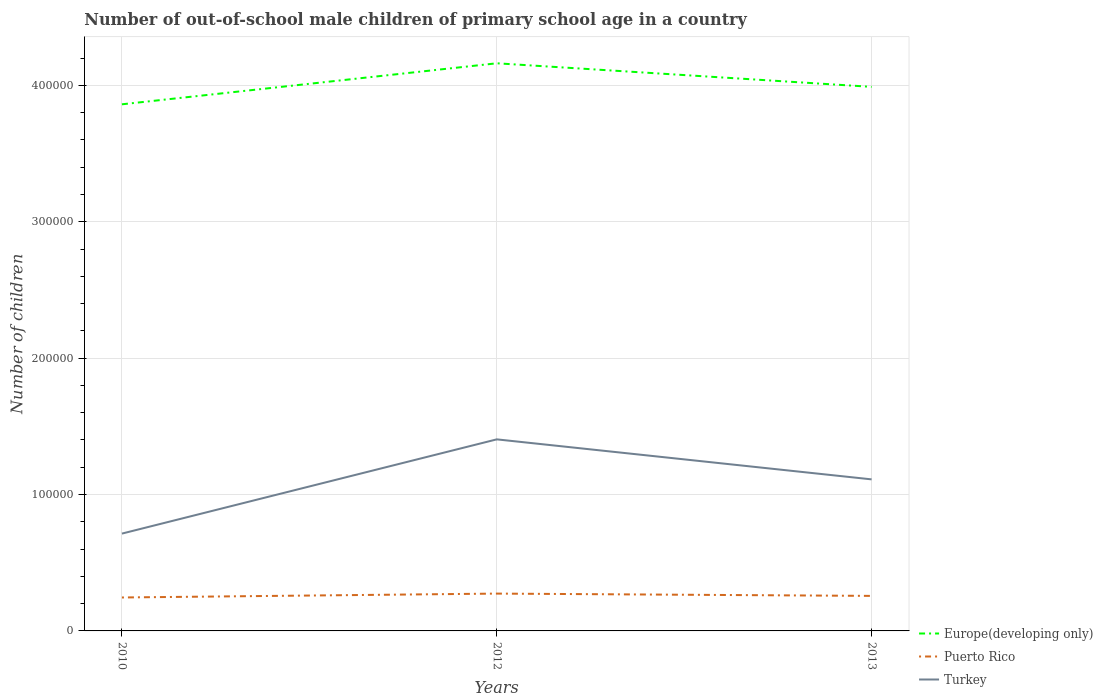Does the line corresponding to Puerto Rico intersect with the line corresponding to Europe(developing only)?
Provide a succinct answer. No. Across all years, what is the maximum number of out-of-school male children in Turkey?
Provide a succinct answer. 7.14e+04. In which year was the number of out-of-school male children in Puerto Rico maximum?
Ensure brevity in your answer.  2010. What is the total number of out-of-school male children in Turkey in the graph?
Offer a very short reply. -6.91e+04. What is the difference between the highest and the second highest number of out-of-school male children in Turkey?
Give a very brief answer. 6.91e+04. What is the difference between the highest and the lowest number of out-of-school male children in Turkey?
Keep it short and to the point. 2. How many lines are there?
Your answer should be compact. 3. What is the difference between two consecutive major ticks on the Y-axis?
Ensure brevity in your answer.  1.00e+05. How many legend labels are there?
Provide a succinct answer. 3. How are the legend labels stacked?
Offer a terse response. Vertical. What is the title of the graph?
Offer a terse response. Number of out-of-school male children of primary school age in a country. Does "Other small states" appear as one of the legend labels in the graph?
Keep it short and to the point. No. What is the label or title of the X-axis?
Make the answer very short. Years. What is the label or title of the Y-axis?
Make the answer very short. Number of children. What is the Number of children in Europe(developing only) in 2010?
Offer a terse response. 3.86e+05. What is the Number of children in Puerto Rico in 2010?
Provide a short and direct response. 2.45e+04. What is the Number of children of Turkey in 2010?
Provide a succinct answer. 7.14e+04. What is the Number of children in Europe(developing only) in 2012?
Ensure brevity in your answer.  4.16e+05. What is the Number of children in Puerto Rico in 2012?
Ensure brevity in your answer.  2.74e+04. What is the Number of children of Turkey in 2012?
Offer a very short reply. 1.40e+05. What is the Number of children in Europe(developing only) in 2013?
Offer a very short reply. 3.99e+05. What is the Number of children in Puerto Rico in 2013?
Keep it short and to the point. 2.57e+04. What is the Number of children in Turkey in 2013?
Make the answer very short. 1.11e+05. Across all years, what is the maximum Number of children in Europe(developing only)?
Offer a very short reply. 4.16e+05. Across all years, what is the maximum Number of children in Puerto Rico?
Offer a very short reply. 2.74e+04. Across all years, what is the maximum Number of children in Turkey?
Keep it short and to the point. 1.40e+05. Across all years, what is the minimum Number of children in Europe(developing only)?
Your answer should be compact. 3.86e+05. Across all years, what is the minimum Number of children of Puerto Rico?
Keep it short and to the point. 2.45e+04. Across all years, what is the minimum Number of children in Turkey?
Your answer should be very brief. 7.14e+04. What is the total Number of children of Europe(developing only) in the graph?
Your answer should be compact. 1.20e+06. What is the total Number of children in Puerto Rico in the graph?
Give a very brief answer. 7.76e+04. What is the total Number of children in Turkey in the graph?
Offer a very short reply. 3.23e+05. What is the difference between the Number of children of Europe(developing only) in 2010 and that in 2012?
Your answer should be compact. -3.01e+04. What is the difference between the Number of children in Puerto Rico in 2010 and that in 2012?
Your answer should be very brief. -2856. What is the difference between the Number of children of Turkey in 2010 and that in 2012?
Make the answer very short. -6.91e+04. What is the difference between the Number of children in Europe(developing only) in 2010 and that in 2013?
Ensure brevity in your answer.  -1.28e+04. What is the difference between the Number of children of Puerto Rico in 2010 and that in 2013?
Offer a very short reply. -1165. What is the difference between the Number of children in Turkey in 2010 and that in 2013?
Your response must be concise. -3.98e+04. What is the difference between the Number of children of Europe(developing only) in 2012 and that in 2013?
Provide a short and direct response. 1.73e+04. What is the difference between the Number of children of Puerto Rico in 2012 and that in 2013?
Provide a succinct answer. 1691. What is the difference between the Number of children in Turkey in 2012 and that in 2013?
Provide a short and direct response. 2.93e+04. What is the difference between the Number of children in Europe(developing only) in 2010 and the Number of children in Puerto Rico in 2012?
Your answer should be compact. 3.59e+05. What is the difference between the Number of children in Europe(developing only) in 2010 and the Number of children in Turkey in 2012?
Your answer should be compact. 2.46e+05. What is the difference between the Number of children of Puerto Rico in 2010 and the Number of children of Turkey in 2012?
Offer a very short reply. -1.16e+05. What is the difference between the Number of children of Europe(developing only) in 2010 and the Number of children of Puerto Rico in 2013?
Offer a very short reply. 3.60e+05. What is the difference between the Number of children in Europe(developing only) in 2010 and the Number of children in Turkey in 2013?
Your response must be concise. 2.75e+05. What is the difference between the Number of children of Puerto Rico in 2010 and the Number of children of Turkey in 2013?
Ensure brevity in your answer.  -8.66e+04. What is the difference between the Number of children of Europe(developing only) in 2012 and the Number of children of Puerto Rico in 2013?
Keep it short and to the point. 3.91e+05. What is the difference between the Number of children in Europe(developing only) in 2012 and the Number of children in Turkey in 2013?
Make the answer very short. 3.05e+05. What is the difference between the Number of children in Puerto Rico in 2012 and the Number of children in Turkey in 2013?
Offer a terse response. -8.38e+04. What is the average Number of children of Europe(developing only) per year?
Your response must be concise. 4.00e+05. What is the average Number of children of Puerto Rico per year?
Your answer should be compact. 2.59e+04. What is the average Number of children of Turkey per year?
Ensure brevity in your answer.  1.08e+05. In the year 2010, what is the difference between the Number of children in Europe(developing only) and Number of children in Puerto Rico?
Provide a succinct answer. 3.62e+05. In the year 2010, what is the difference between the Number of children of Europe(developing only) and Number of children of Turkey?
Provide a succinct answer. 3.15e+05. In the year 2010, what is the difference between the Number of children in Puerto Rico and Number of children in Turkey?
Make the answer very short. -4.68e+04. In the year 2012, what is the difference between the Number of children in Europe(developing only) and Number of children in Puerto Rico?
Offer a terse response. 3.89e+05. In the year 2012, what is the difference between the Number of children of Europe(developing only) and Number of children of Turkey?
Give a very brief answer. 2.76e+05. In the year 2012, what is the difference between the Number of children in Puerto Rico and Number of children in Turkey?
Offer a terse response. -1.13e+05. In the year 2013, what is the difference between the Number of children of Europe(developing only) and Number of children of Puerto Rico?
Provide a succinct answer. 3.73e+05. In the year 2013, what is the difference between the Number of children in Europe(developing only) and Number of children in Turkey?
Offer a terse response. 2.88e+05. In the year 2013, what is the difference between the Number of children in Puerto Rico and Number of children in Turkey?
Ensure brevity in your answer.  -8.54e+04. What is the ratio of the Number of children of Europe(developing only) in 2010 to that in 2012?
Your answer should be very brief. 0.93. What is the ratio of the Number of children in Puerto Rico in 2010 to that in 2012?
Ensure brevity in your answer.  0.9. What is the ratio of the Number of children of Turkey in 2010 to that in 2012?
Ensure brevity in your answer.  0.51. What is the ratio of the Number of children of Europe(developing only) in 2010 to that in 2013?
Keep it short and to the point. 0.97. What is the ratio of the Number of children of Puerto Rico in 2010 to that in 2013?
Offer a very short reply. 0.95. What is the ratio of the Number of children in Turkey in 2010 to that in 2013?
Offer a terse response. 0.64. What is the ratio of the Number of children of Europe(developing only) in 2012 to that in 2013?
Keep it short and to the point. 1.04. What is the ratio of the Number of children in Puerto Rico in 2012 to that in 2013?
Your answer should be compact. 1.07. What is the ratio of the Number of children of Turkey in 2012 to that in 2013?
Offer a terse response. 1.26. What is the difference between the highest and the second highest Number of children in Europe(developing only)?
Provide a succinct answer. 1.73e+04. What is the difference between the highest and the second highest Number of children of Puerto Rico?
Your response must be concise. 1691. What is the difference between the highest and the second highest Number of children of Turkey?
Keep it short and to the point. 2.93e+04. What is the difference between the highest and the lowest Number of children of Europe(developing only)?
Offer a terse response. 3.01e+04. What is the difference between the highest and the lowest Number of children in Puerto Rico?
Give a very brief answer. 2856. What is the difference between the highest and the lowest Number of children in Turkey?
Offer a very short reply. 6.91e+04. 